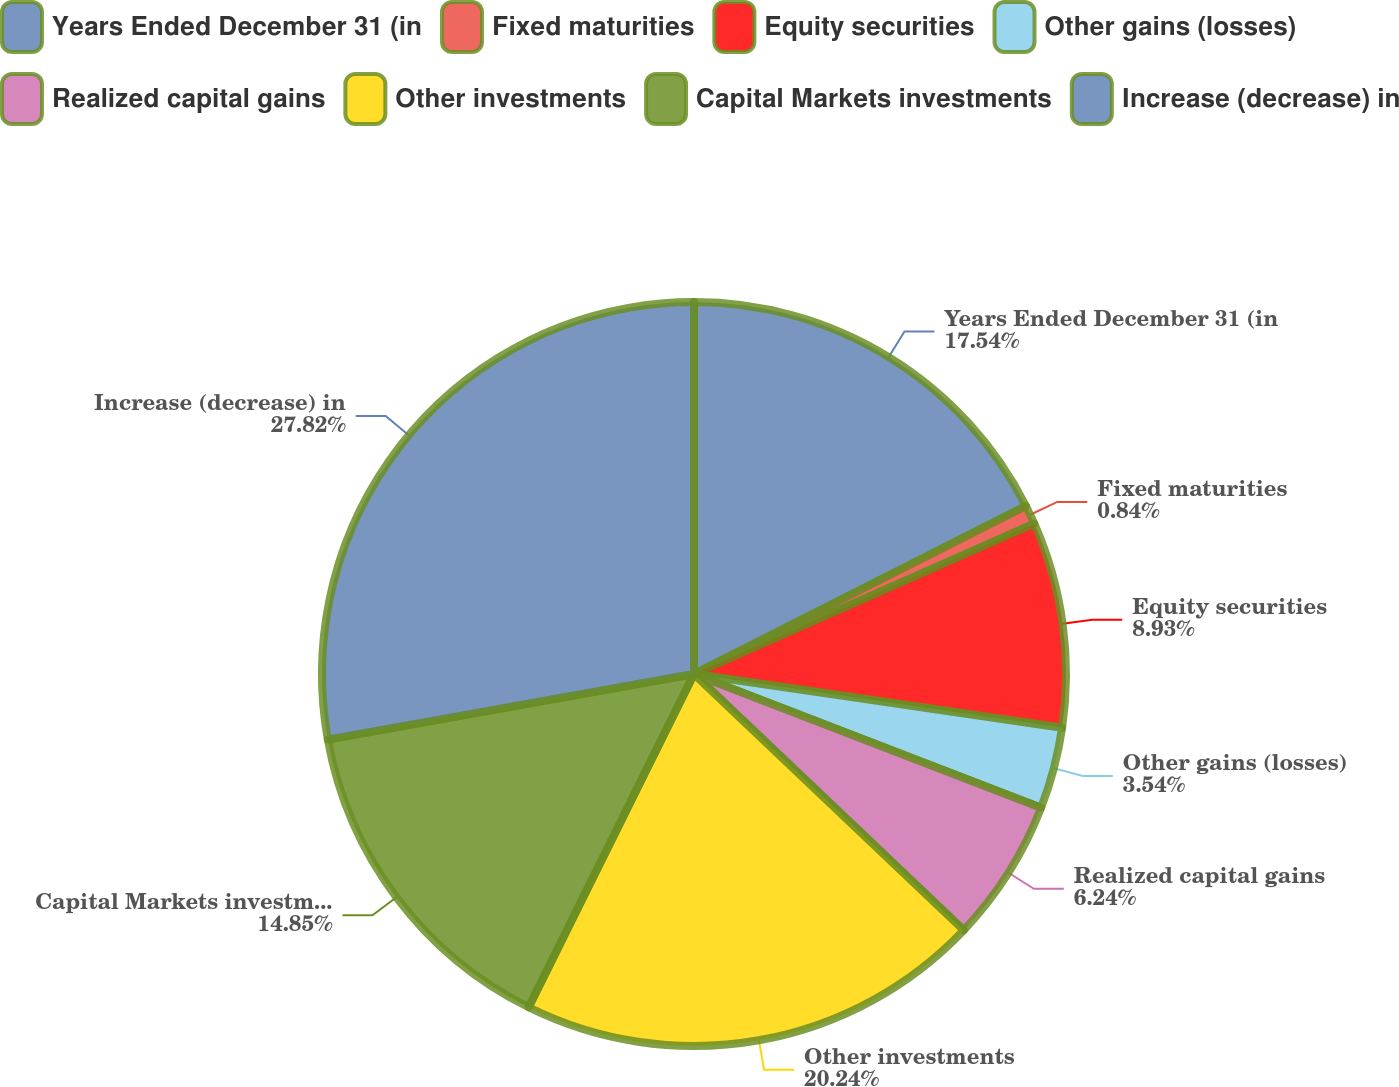<chart> <loc_0><loc_0><loc_500><loc_500><pie_chart><fcel>Years Ended December 31 (in<fcel>Fixed maturities<fcel>Equity securities<fcel>Other gains (losses)<fcel>Realized capital gains<fcel>Other investments<fcel>Capital Markets investments<fcel>Increase (decrease) in<nl><fcel>17.54%<fcel>0.84%<fcel>8.93%<fcel>3.54%<fcel>6.24%<fcel>20.24%<fcel>14.85%<fcel>27.82%<nl></chart> 